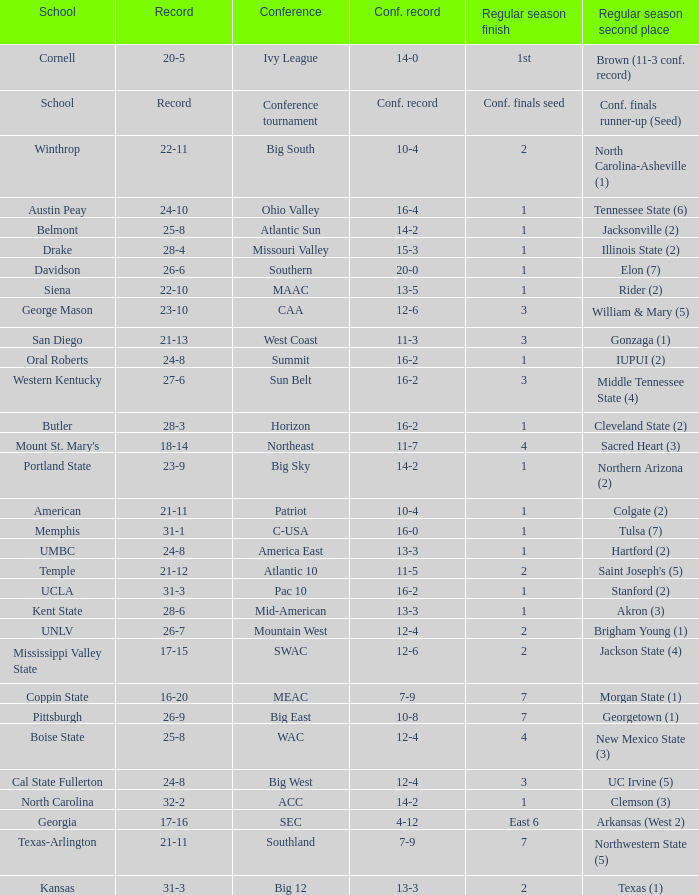What was the overall record of UMBC? 24-8. 